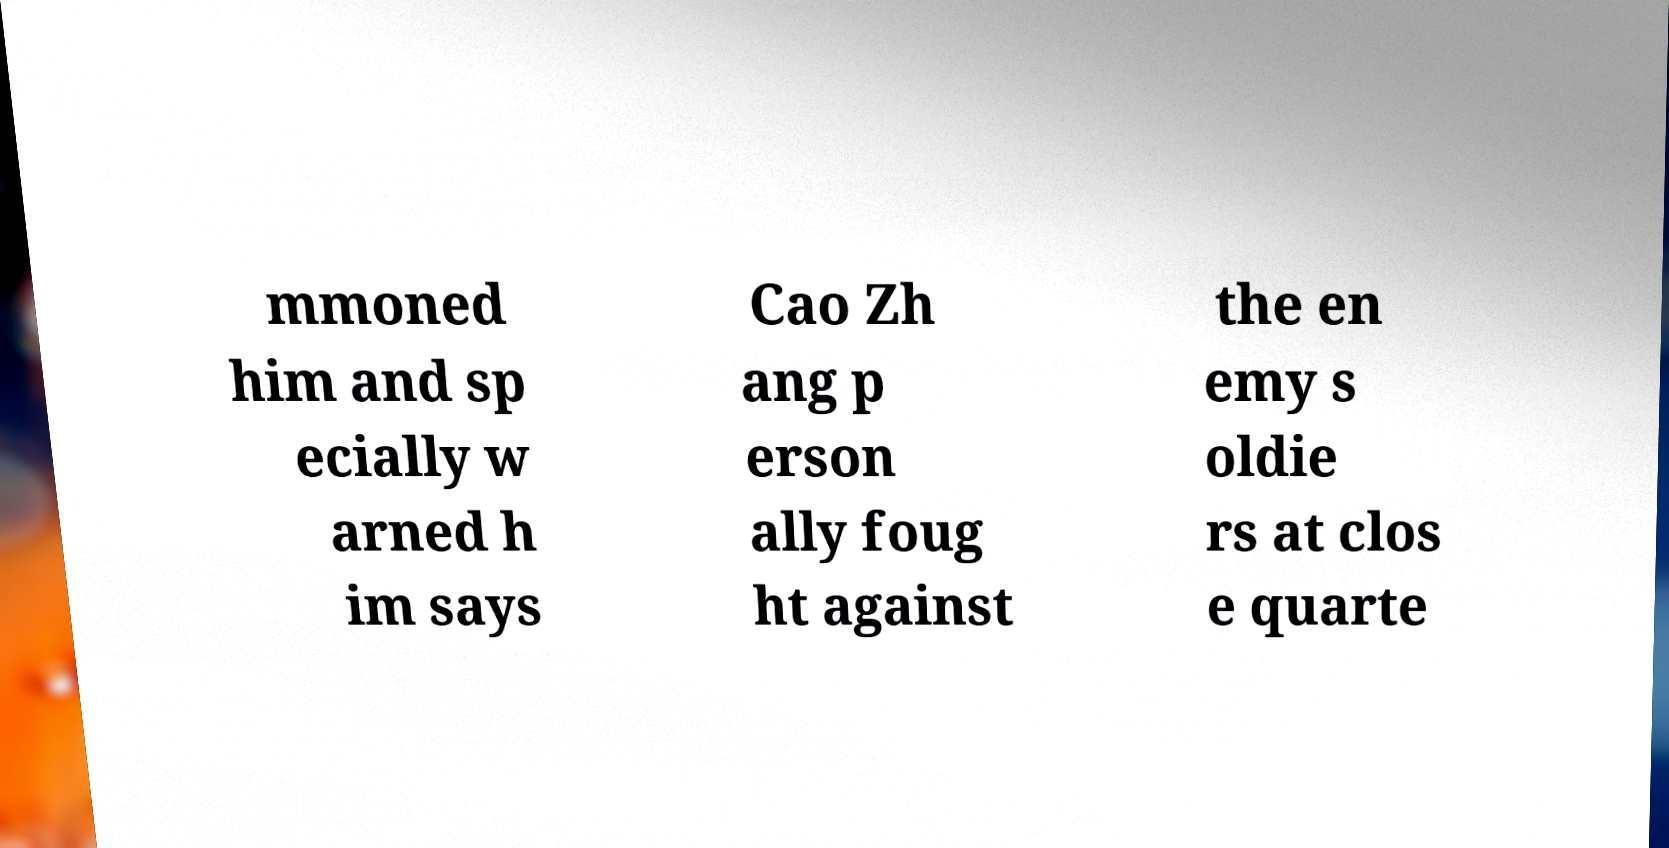For documentation purposes, I need the text within this image transcribed. Could you provide that? mmoned him and sp ecially w arned h im says Cao Zh ang p erson ally foug ht against the en emy s oldie rs at clos e quarte 